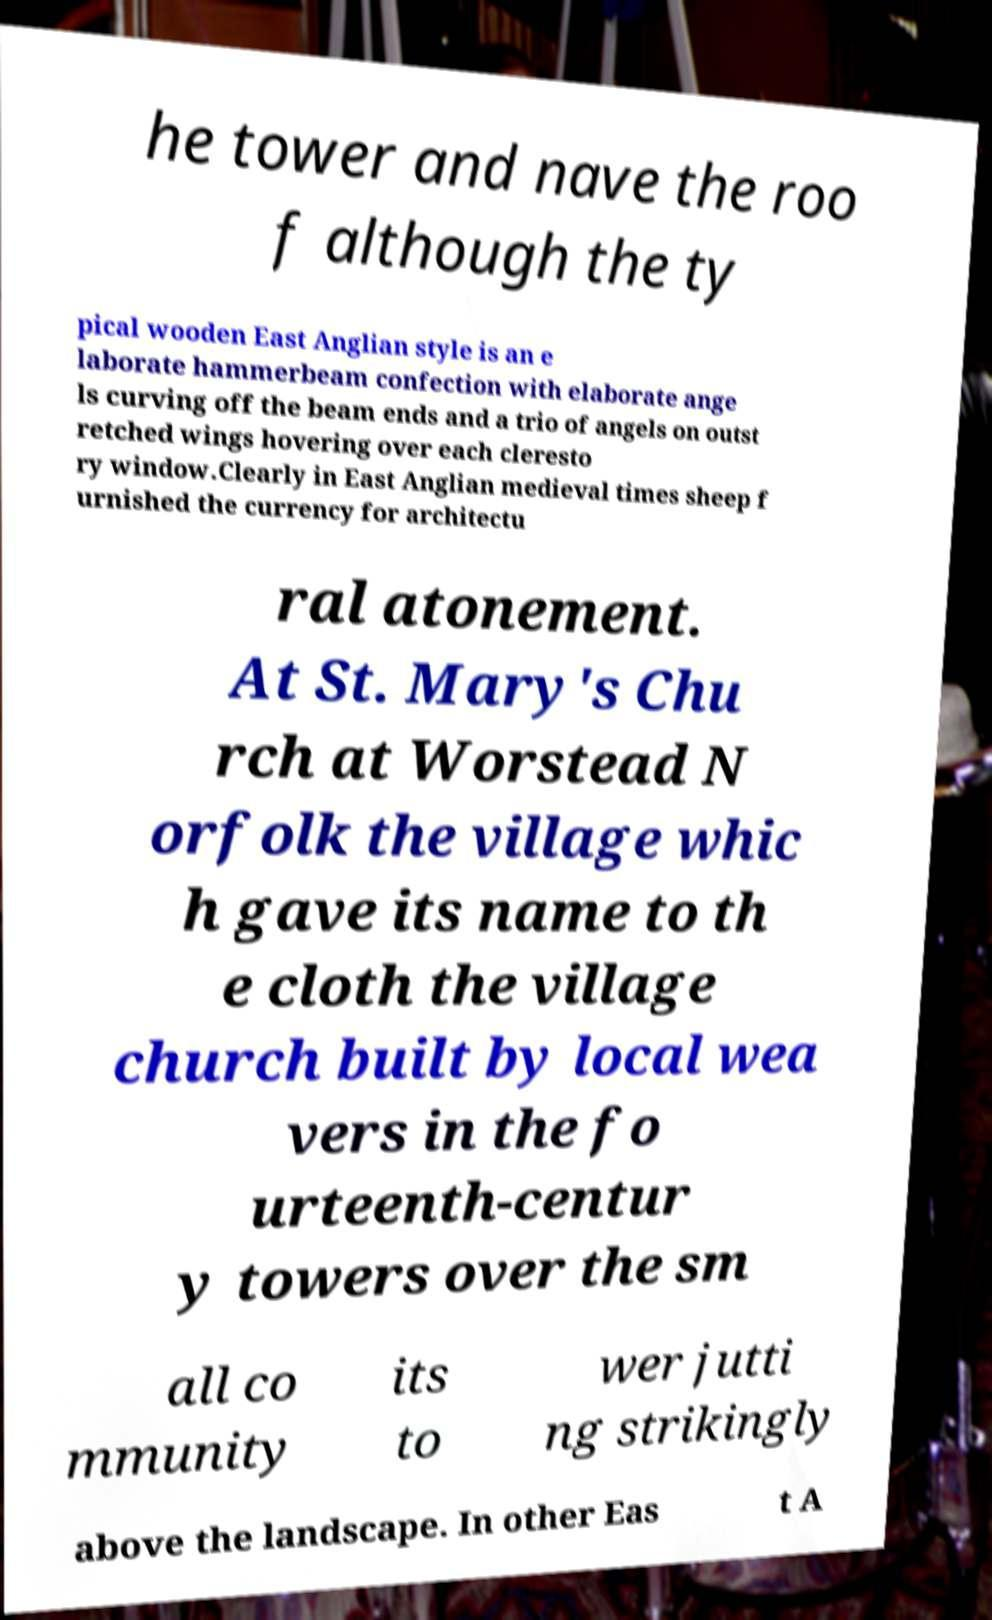Could you assist in decoding the text presented in this image and type it out clearly? he tower and nave the roo f although the ty pical wooden East Anglian style is an e laborate hammerbeam confection with elaborate ange ls curving off the beam ends and a trio of angels on outst retched wings hovering over each cleresto ry window.Clearly in East Anglian medieval times sheep f urnished the currency for architectu ral atonement. At St. Mary's Chu rch at Worstead N orfolk the village whic h gave its name to th e cloth the village church built by local wea vers in the fo urteenth-centur y towers over the sm all co mmunity its to wer jutti ng strikingly above the landscape. In other Eas t A 